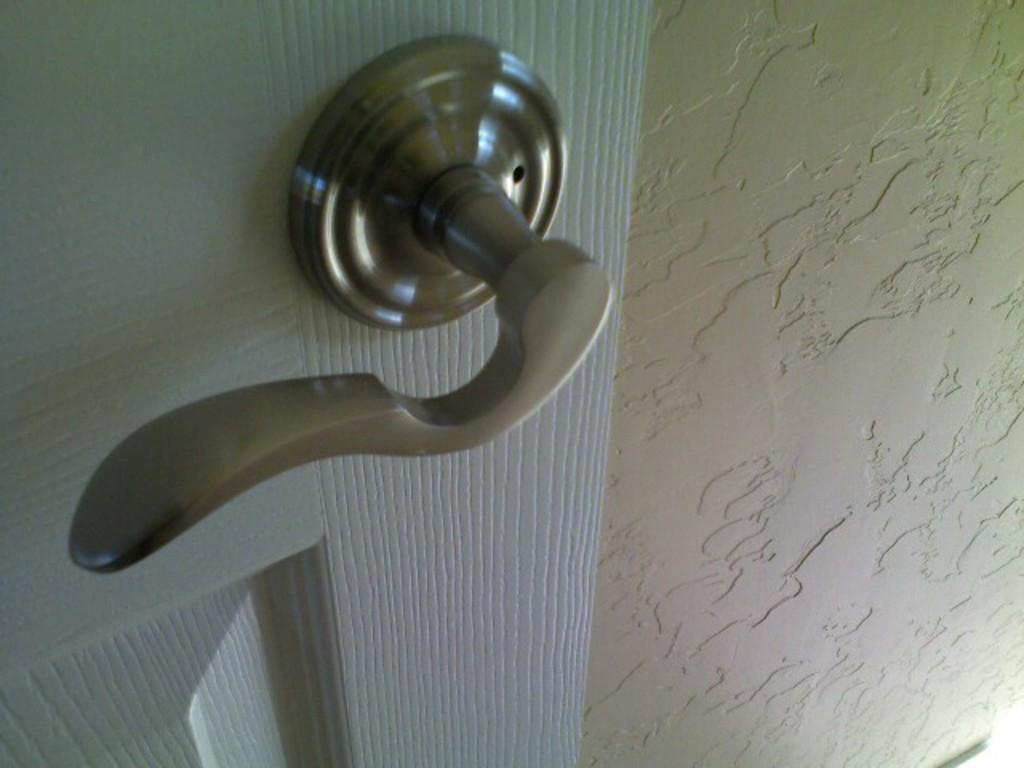What type of door is visible in the image? There is a wooden door in the image. What feature is present on the wooden door? The wooden door has a door handle. What else can be seen in the image besides the door? There is a wall in the image. What type of grain is being used to make the butter in the image? There is no grain or butter present in the image; it only features a wooden door with a door handle and a wall. 